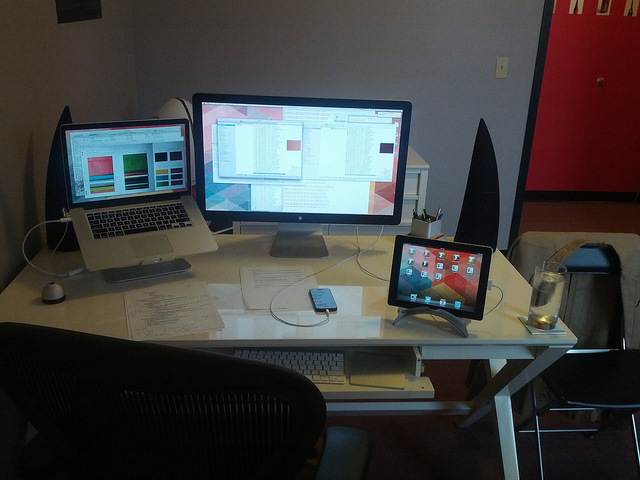What kind of accessories are connected to the computers? There's an Apple Magic Mouse and a keyboard, likely a Magic Keyboard, paired with the iMac. A smartphone also sits atop a docking station, connected to the MacBook. In the background, a pair of standalone speakers are visible, which may be connected to either computer for enhanced audio.  Does the lighting in the room affect the work environment? Yes, the ambient lighting looks soft and diffused, possibly providing a comfortable brightness level for work without excessive glare on the screens. However, for long hours of work, especially at night, additional task lighting might be beneficial to prevent eye strain. 